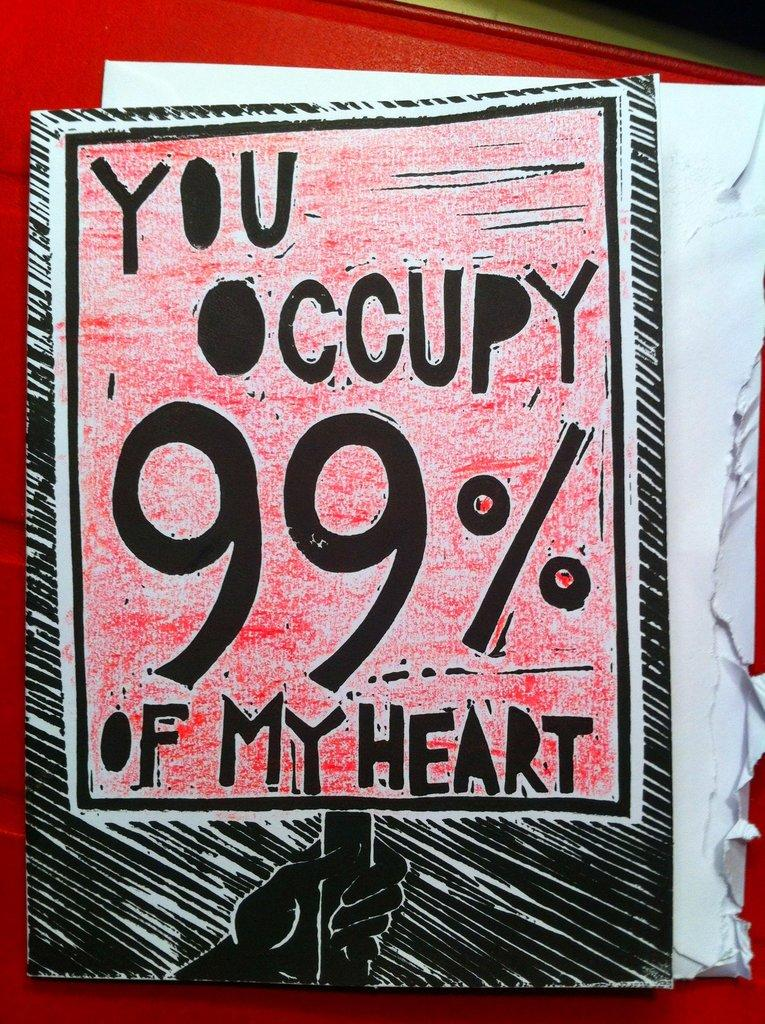<image>
Summarize the visual content of the image. a picture with a quote about occupying the heart 